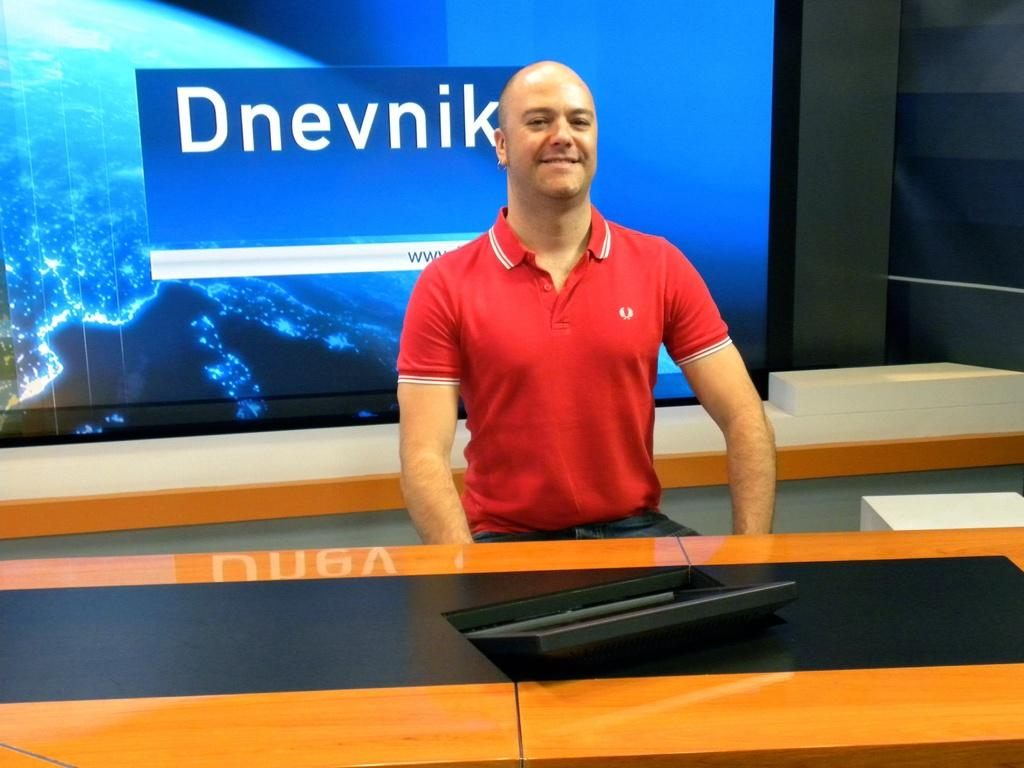What is the man in the image doing? The man is sitting in the center of the image and smiling. What can be seen at the bottom of the image? There is a table at the bottom of the image. What is on the table? There is an object on the table. What is visible in the background of the image? There is a screen and a wall in the background of the image. What type of yarn is being used to support the screen in the image? There is no yarn or support for the screen visible in the image. How many nets are present in the image? There are no nets present in the image. 